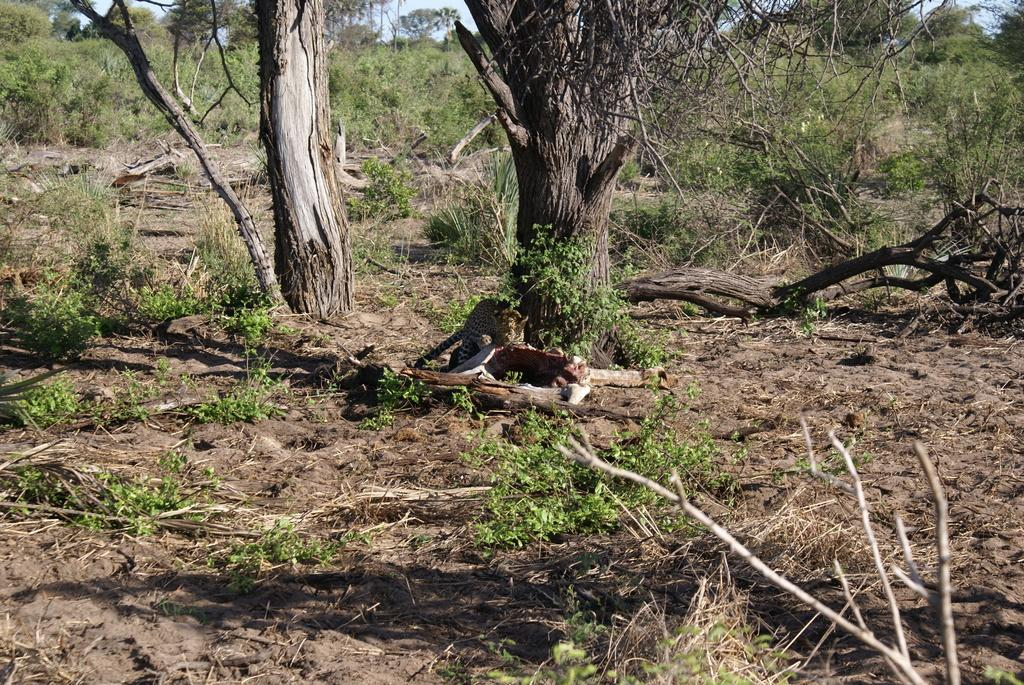What animal is in the center of the image? There is a cheetah in the center of the image. What is the cheetah doing in the image? The cheetah is eating meat in the image. What can be seen in the background of the image? There are trees and the sky visible in the background of the image. What type of vegetation is at the bottom of the image? There is grass at the bottom of the image. Where is the harbor located in the image? There is no harbor present in the image; it features a cheetah eating meat. What type of trousers is the cheetah wearing in the image? Cheetahs do not wear clothing, so the question is not applicable to the image. 